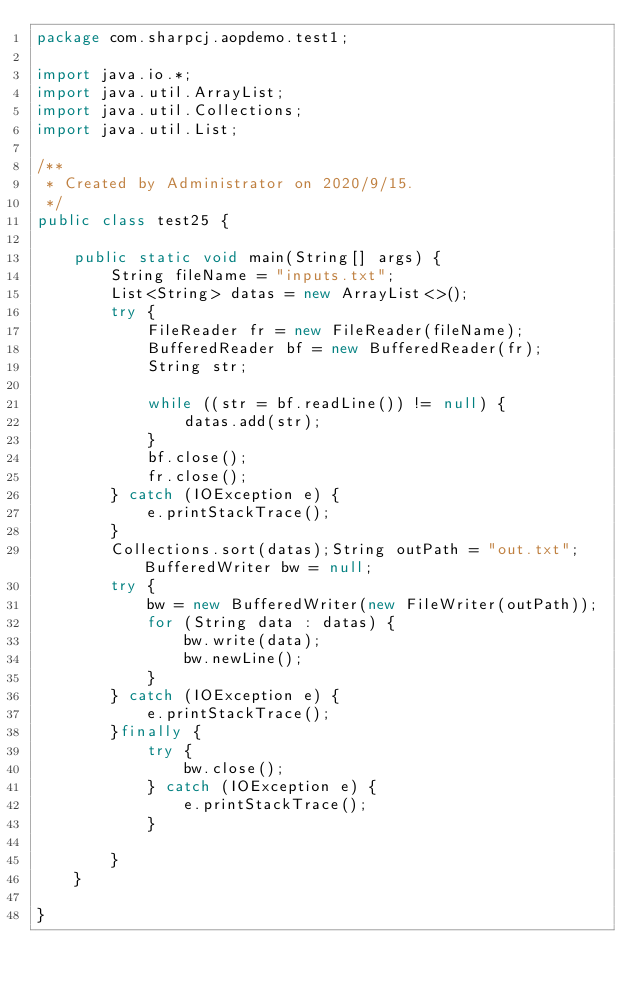<code> <loc_0><loc_0><loc_500><loc_500><_Java_>package com.sharpcj.aopdemo.test1;

import java.io.*;
import java.util.ArrayList;
import java.util.Collections;
import java.util.List;

/**
 * Created by Administrator on 2020/9/15.
 */
public class test25 {

    public static void main(String[] args) {
        String fileName = "inputs.txt";
        List<String> datas = new ArrayList<>();
        try {
            FileReader fr = new FileReader(fileName);
            BufferedReader bf = new BufferedReader(fr);
            String str;

            while ((str = bf.readLine()) != null) {
                datas.add(str);
            }
            bf.close();
            fr.close();
        } catch (IOException e) {
            e.printStackTrace();
        }
        Collections.sort(datas);String outPath = "out.txt";BufferedWriter bw = null;
        try {
            bw = new BufferedWriter(new FileWriter(outPath));
            for (String data : datas) {
                bw.write(data);
                bw.newLine();
            }
        } catch (IOException e) {
            e.printStackTrace();
        }finally {
            try {
                bw.close();
            } catch (IOException e) {
                e.printStackTrace();
            }

        }
    }

}
</code> 